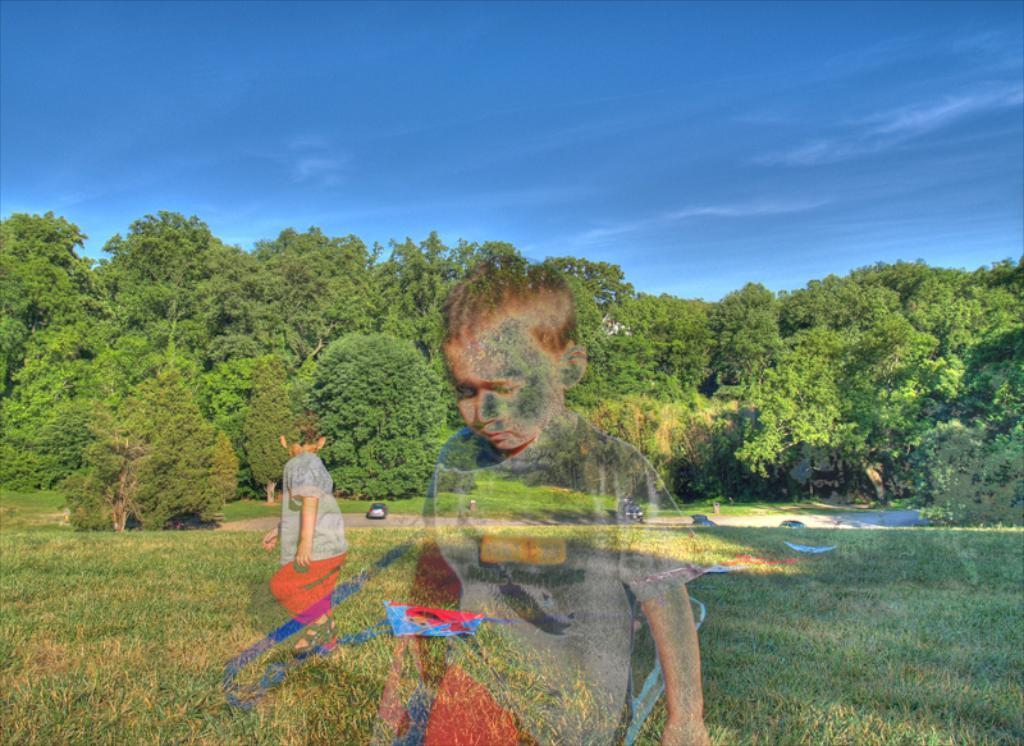What type of picture is in the image? The image contains an edited picture. Who is present in the image? There is a boy in the image. Where is the boy located? The boy is on the grass. What can be seen in the background of the image? There are cars and trees in the background of the image. What is visible at the top of the image? The sky is visible at the top of the image. What type of bottle can be seen in the boy's hand in the image? There is no bottle visible in the boy's hand in the image. What color is the lipstick the boy is wearing in the image? The boy is not wearing lipstick in the image. 